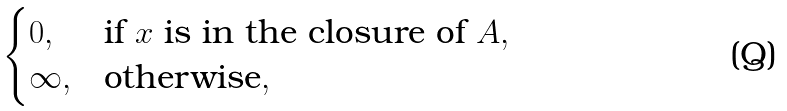<formula> <loc_0><loc_0><loc_500><loc_500>\begin{cases} 0 , & \text {if $x$ is in the closure of $A$} , \\ \infty , & \text {otherwise} , \end{cases}</formula> 